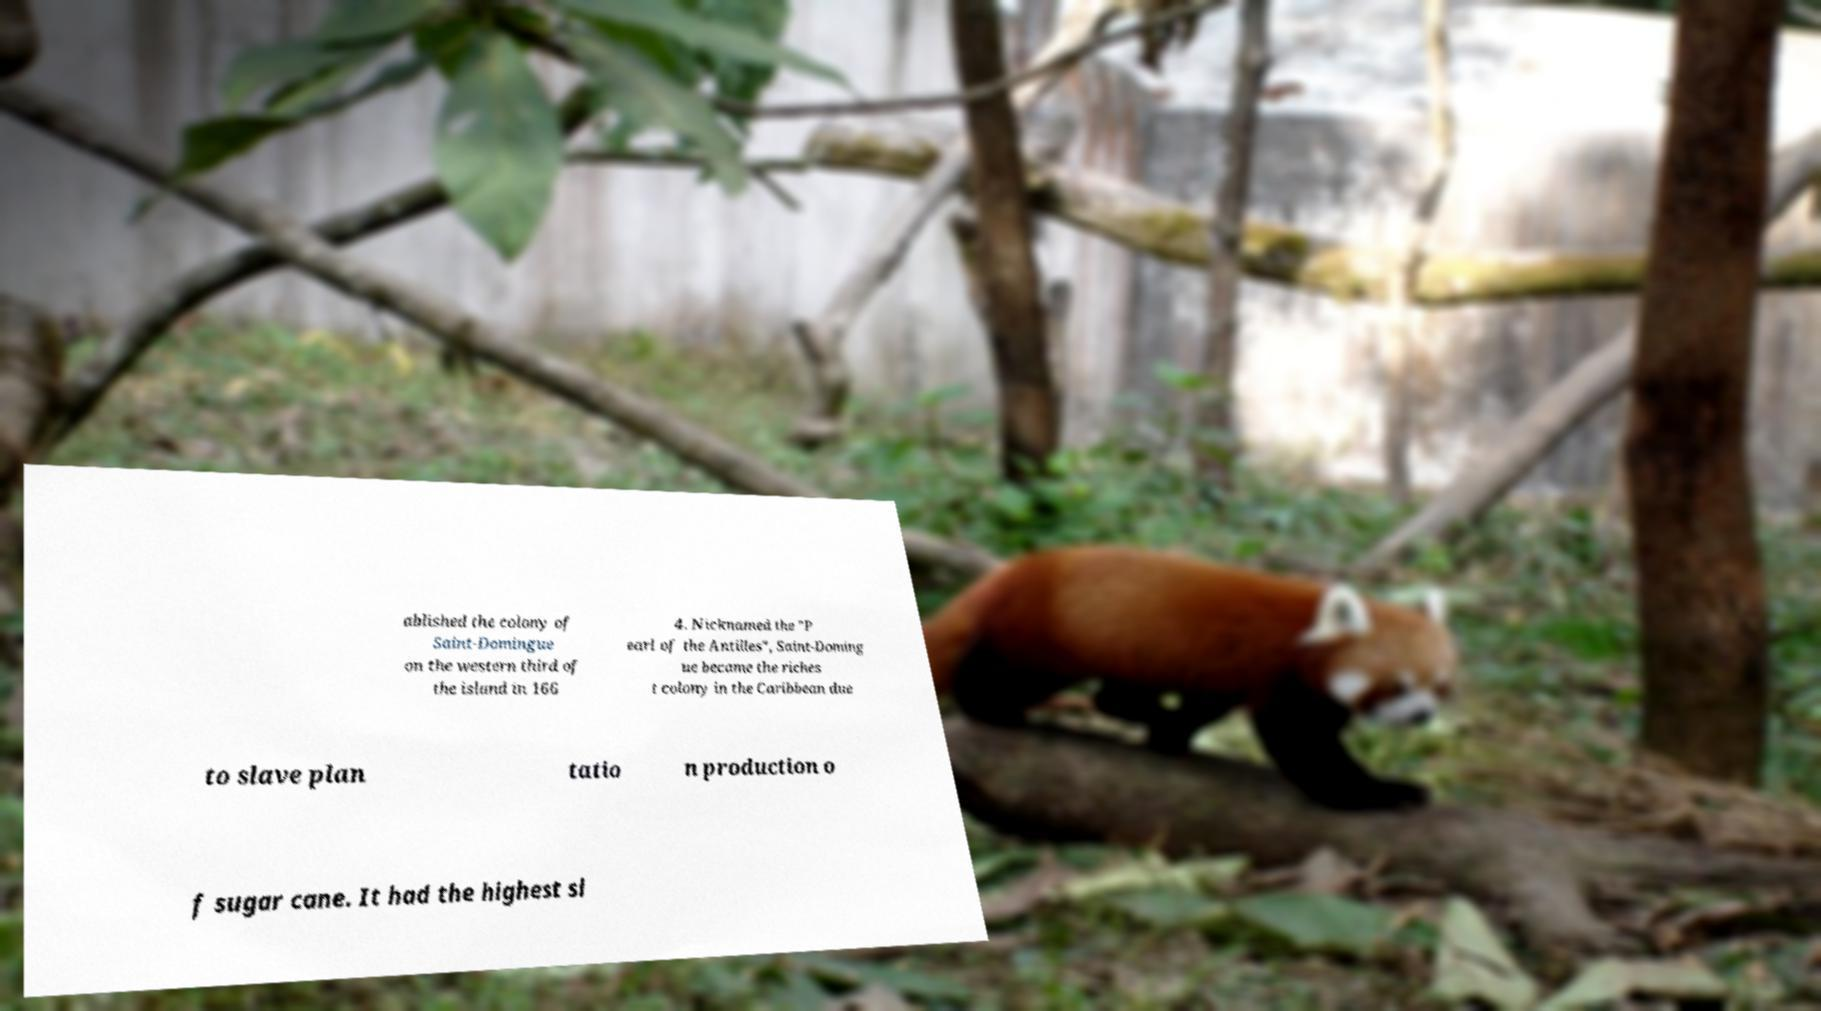Can you accurately transcribe the text from the provided image for me? ablished the colony of Saint-Domingue on the western third of the island in 166 4. Nicknamed the "P earl of the Antilles", Saint-Doming ue became the riches t colony in the Caribbean due to slave plan tatio n production o f sugar cane. It had the highest sl 